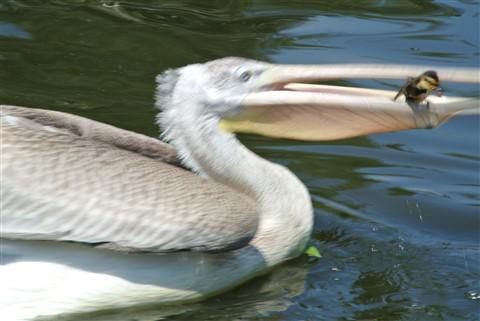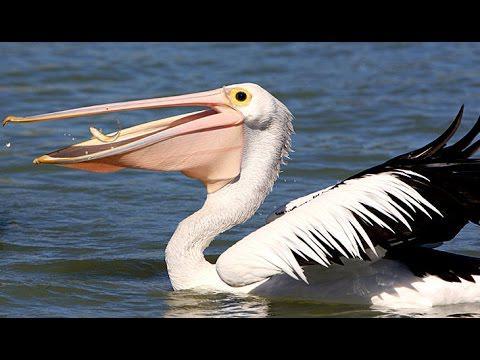The first image is the image on the left, the second image is the image on the right. Given the left and right images, does the statement "The bird in the left image has a fish in it's beak." hold true? Answer yes or no. Yes. The first image is the image on the left, the second image is the image on the right. Given the left and right images, does the statement "There a single bird with black and white feathers facing left." hold true? Answer yes or no. Yes. 